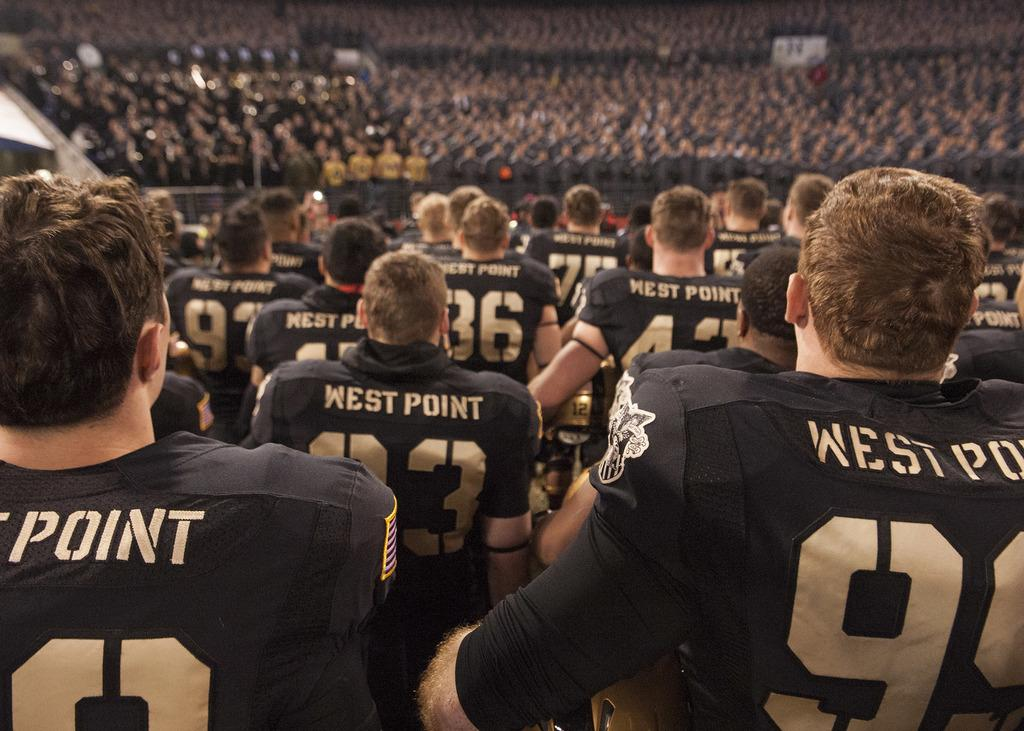What type of image is being described? The image is an animation. How many people are present in the image? There are many people in the image. What are the people wearing? The people are wearing jerseys. Can you describe the background of the image? The background of the image is blurred. What type of breakfast is being served in the image? There is no breakfast present in the image; it is an animation featuring many people wearing jerseys with a blurred background. 